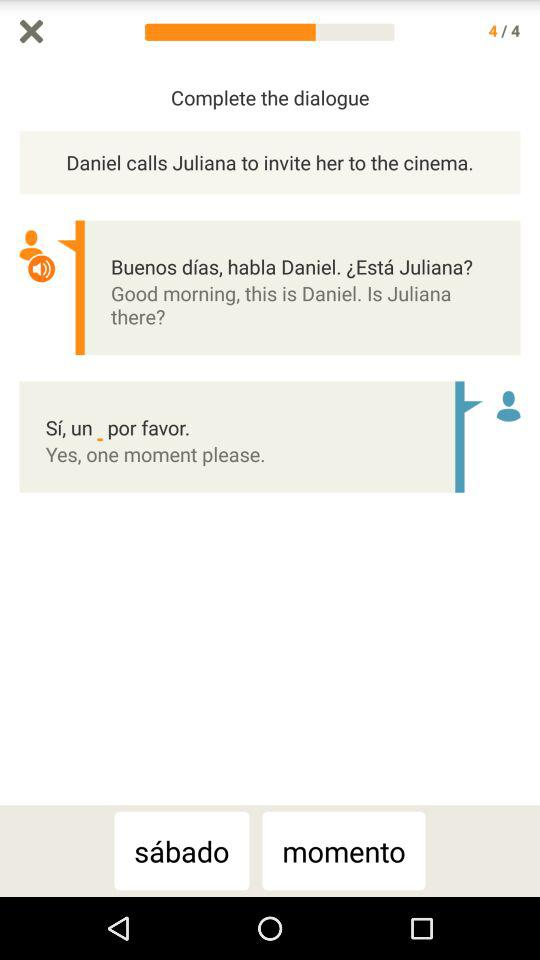What is the total number of questions? The total number of questions is 4. 